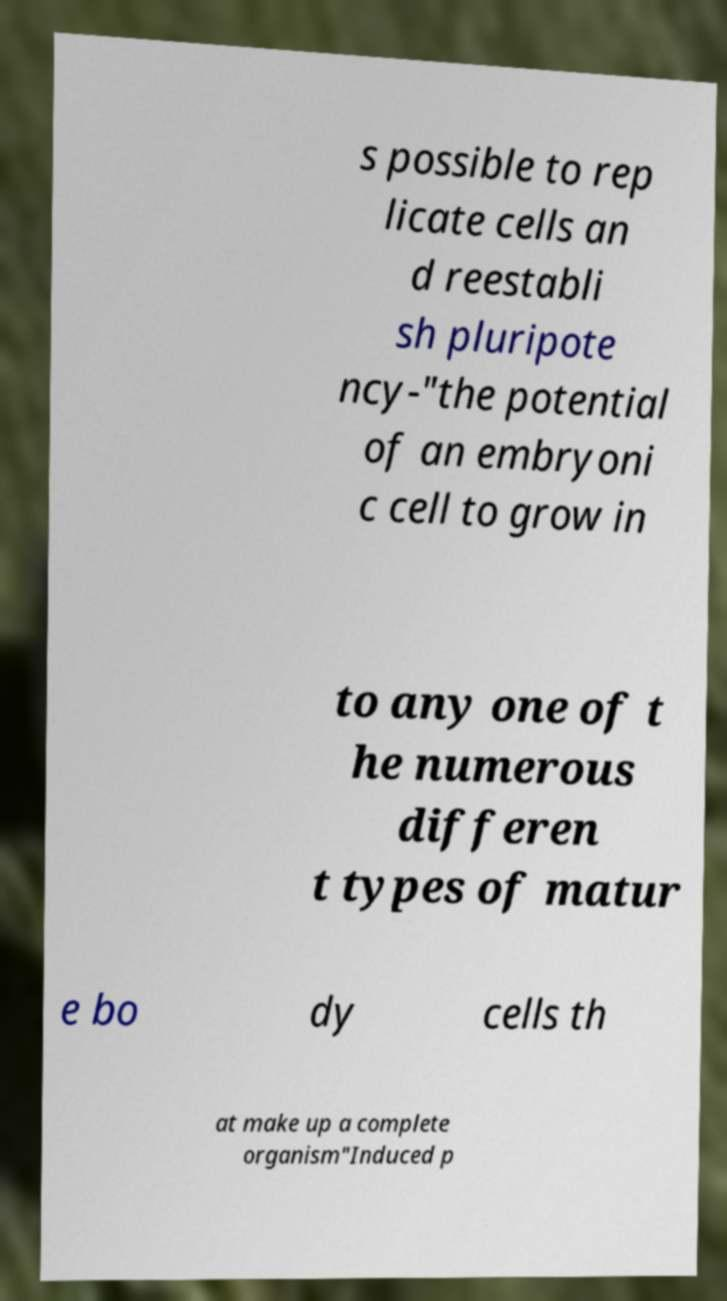For documentation purposes, I need the text within this image transcribed. Could you provide that? s possible to rep licate cells an d reestabli sh pluripote ncy-"the potential of an embryoni c cell to grow in to any one of t he numerous differen t types of matur e bo dy cells th at make up a complete organism"Induced p 